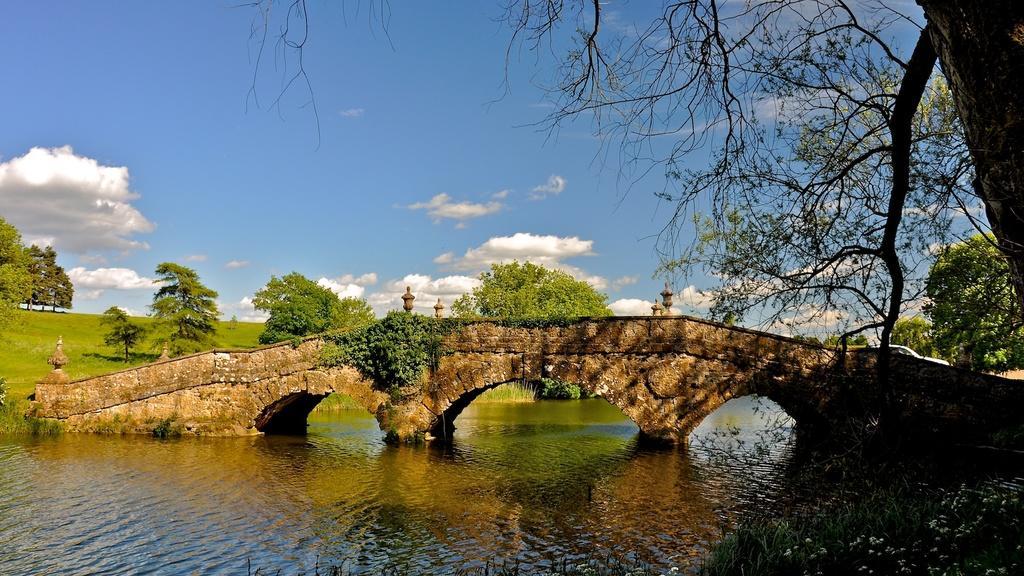Please provide a concise description of this image. In the foreground of this image, there is water and a tree on the right. In the middle, there is a bridge. In the background, there are trees, grassland and the sky. 